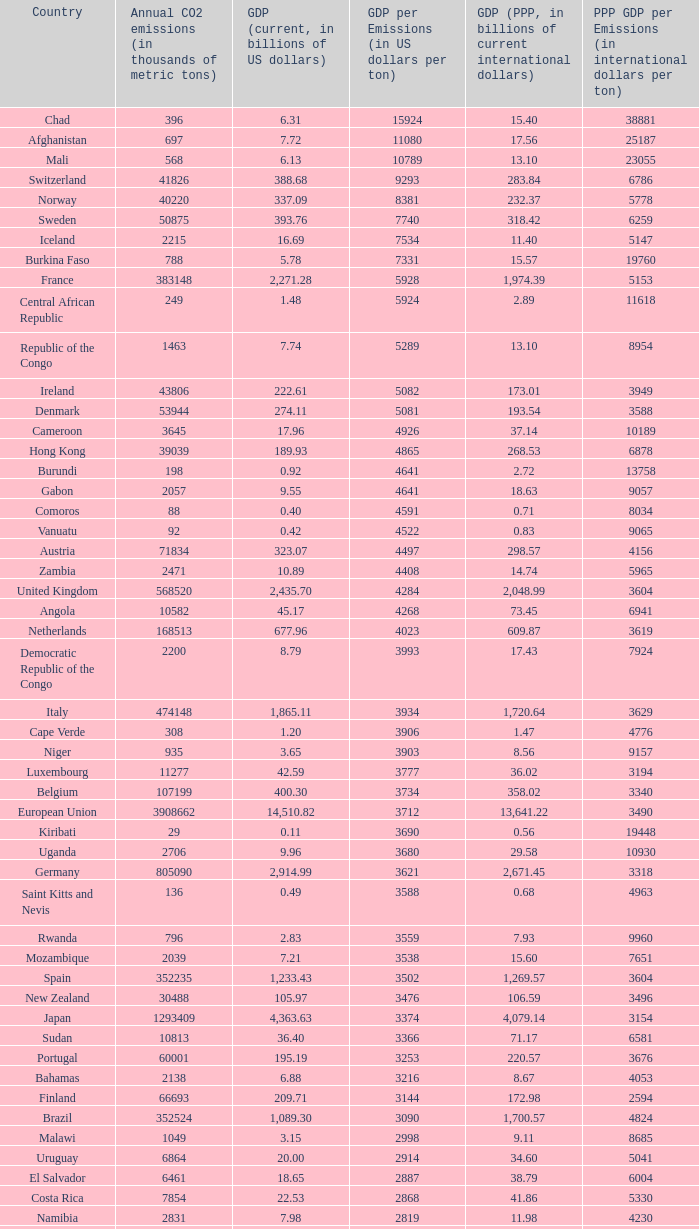With a gdp per emissions value of $3,903 per ton, what is the greatest amount of co2 emissions per year in thousands of metric tons? 935.0. 